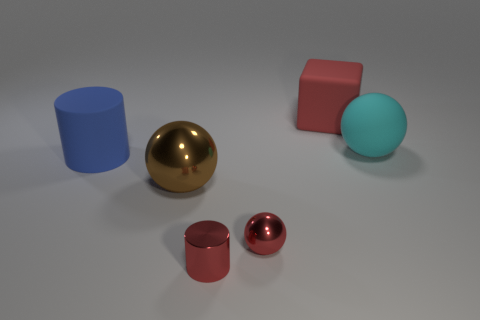Add 4 cyan rubber things. How many objects exist? 10 Subtract all cubes. How many objects are left? 5 Add 4 red cubes. How many red cubes exist? 5 Subtract 1 red spheres. How many objects are left? 5 Subtract all tiny red blocks. Subtract all big cyan spheres. How many objects are left? 5 Add 1 metal objects. How many metal objects are left? 4 